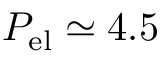<formula> <loc_0><loc_0><loc_500><loc_500>P _ { e l } \simeq 4 . 5</formula> 